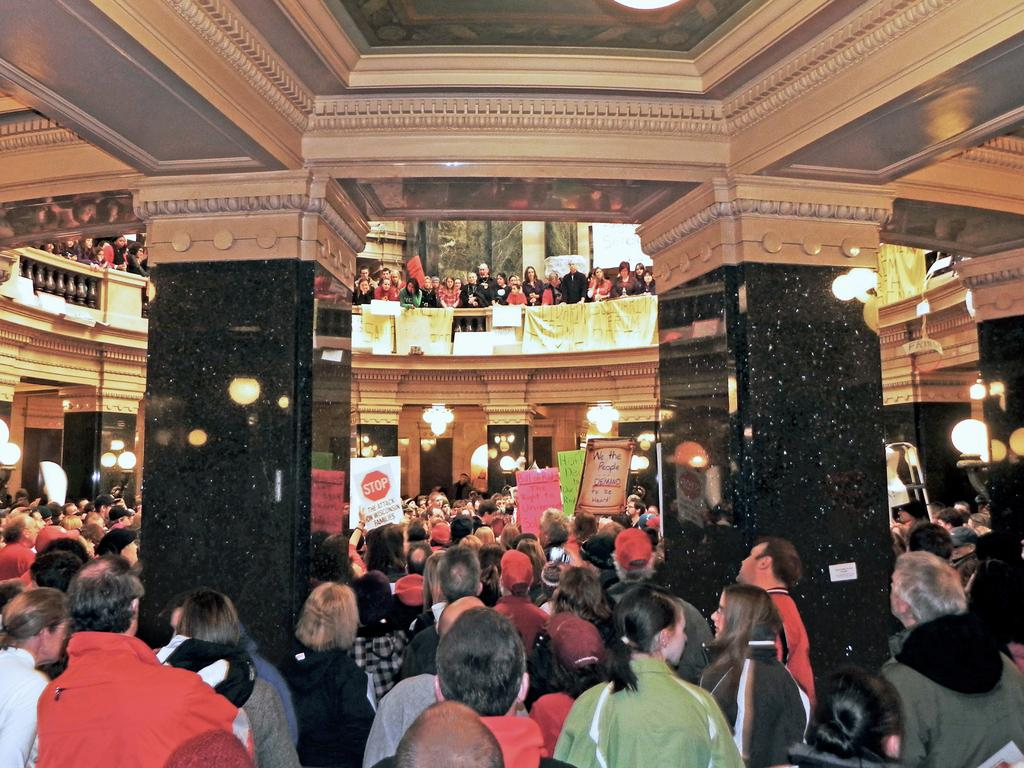How many people are in the image? There is a group of people standing in the image. What can be seen on the boards in the image? There are boards with text in the image. What architectural features are visible in the image? There are pillars visible in the image. What type of lighting is present in the image? There are lights in the image. What type of structure is visible in the image? There is a grille in the image. How many boys are playing with the tent in the image? There is no tent or boys present in the image. 